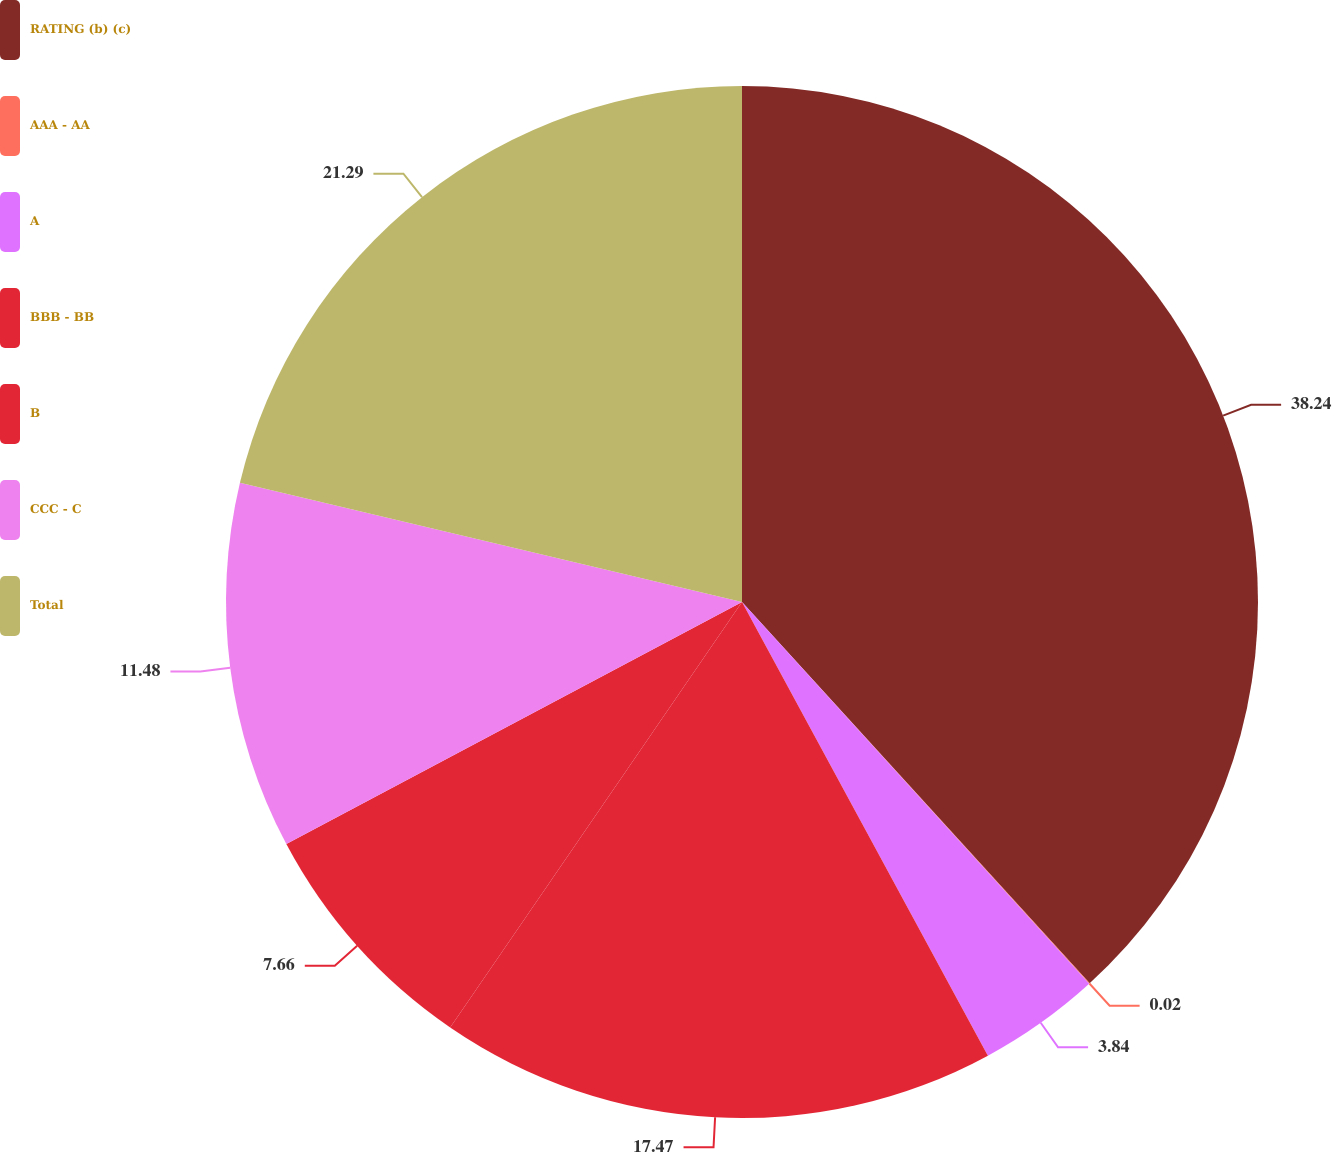<chart> <loc_0><loc_0><loc_500><loc_500><pie_chart><fcel>RATING (b) (c)<fcel>AAA - AA<fcel>A<fcel>BBB - BB<fcel>B<fcel>CCC - C<fcel>Total<nl><fcel>38.23%<fcel>0.02%<fcel>3.84%<fcel>17.47%<fcel>7.66%<fcel>11.48%<fcel>21.29%<nl></chart> 